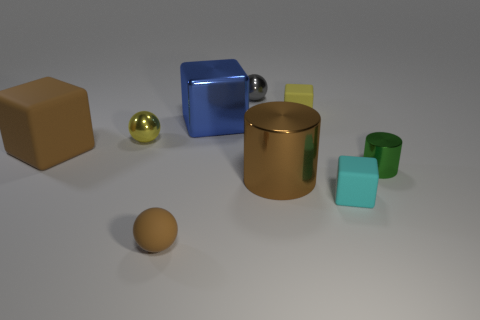Is the number of cubes that are left of the big blue metal object the same as the number of cyan things?
Ensure brevity in your answer.  Yes. There is a small shiny thing behind the small yellow thing right of the small brown thing; are there any tiny metal objects that are behind it?
Your answer should be very brief. No. What material is the gray thing?
Your answer should be very brief. Metal. How many other things are there of the same shape as the large brown rubber object?
Your answer should be very brief. 3. Does the tiny green thing have the same shape as the large brown rubber object?
Offer a very short reply. No. What number of things are either matte blocks behind the large brown block or yellow objects right of the shiny cube?
Offer a very short reply. 1. What number of objects are blue shiny things or small green things?
Offer a terse response. 2. There is a small matte cube in front of the big blue metal thing; what number of tiny gray metal balls are to the right of it?
Offer a terse response. 0. What number of other objects are there of the same size as the blue cube?
Make the answer very short. 2. What is the size of the shiny thing that is the same color as the matte sphere?
Offer a very short reply. Large. 